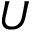<formula> <loc_0><loc_0><loc_500><loc_500>U</formula> 